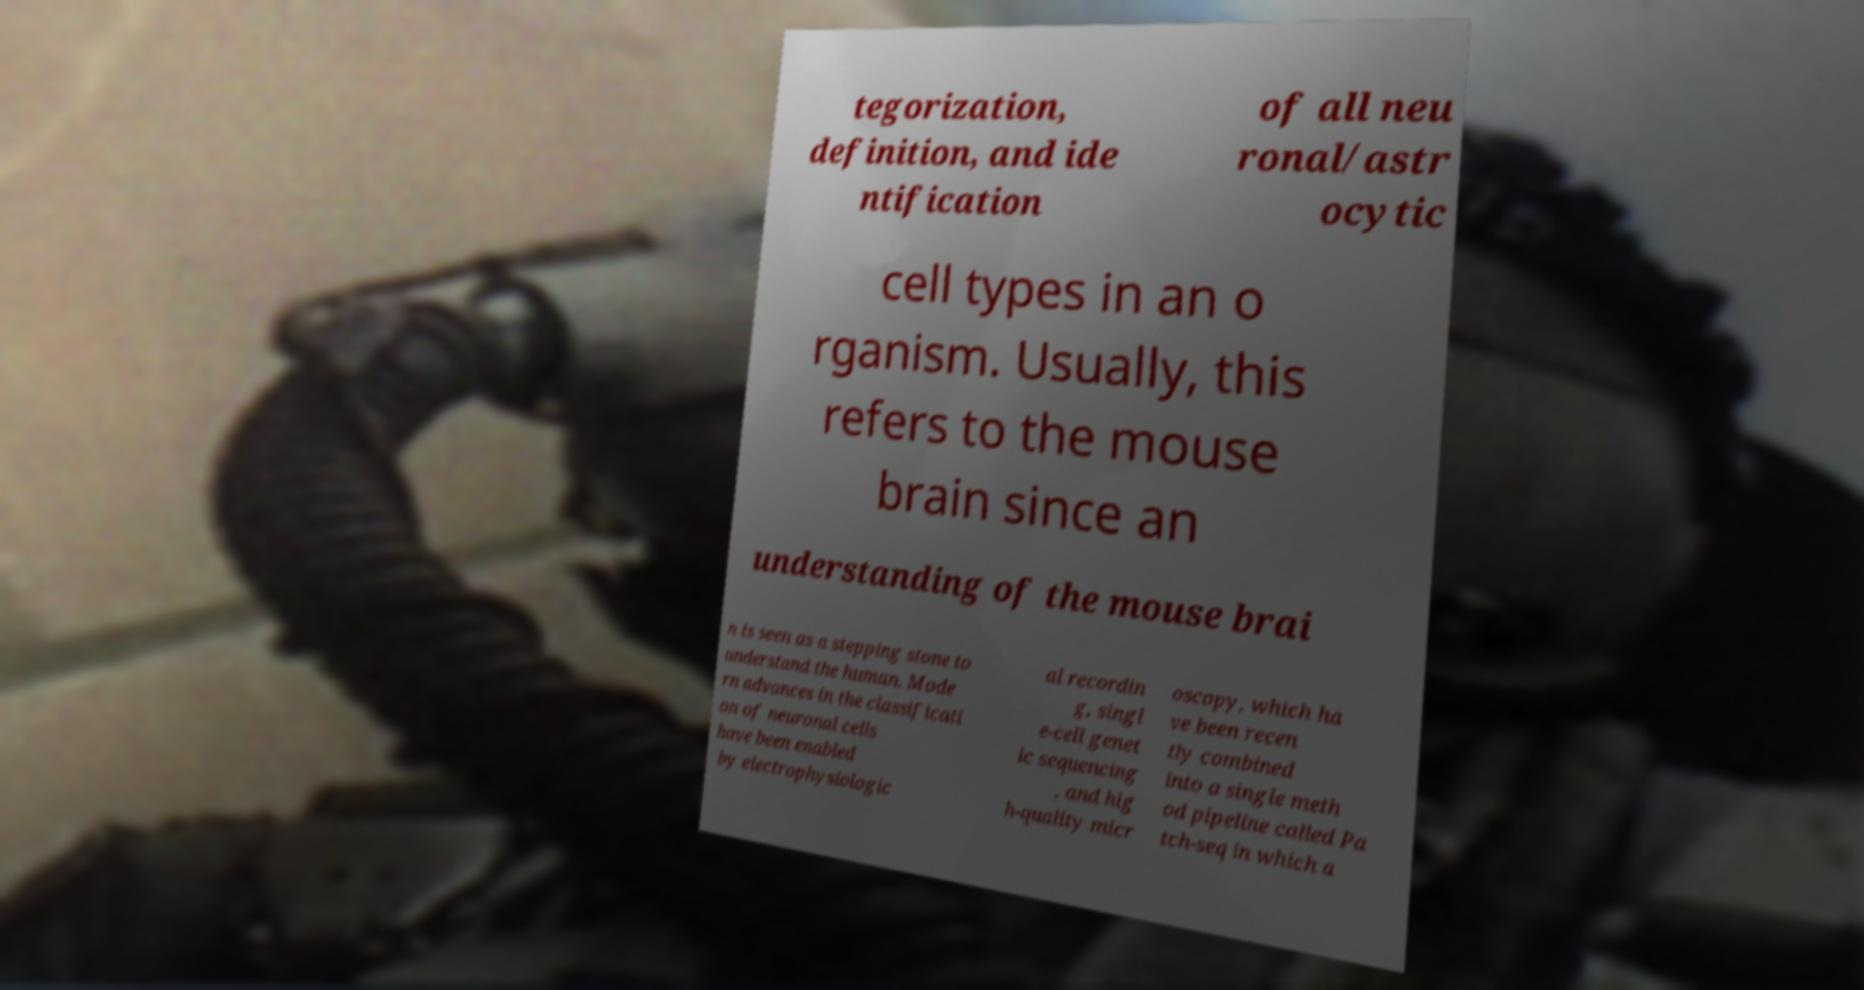Please identify and transcribe the text found in this image. tegorization, definition, and ide ntification of all neu ronal/astr ocytic cell types in an o rganism. Usually, this refers to the mouse brain since an understanding of the mouse brai n is seen as a stepping stone to understand the human. Mode rn advances in the classificati on of neuronal cells have been enabled by electrophysiologic al recordin g, singl e-cell genet ic sequencing , and hig h-quality micr oscopy, which ha ve been recen tly combined into a single meth od pipeline called Pa tch-seq in which a 